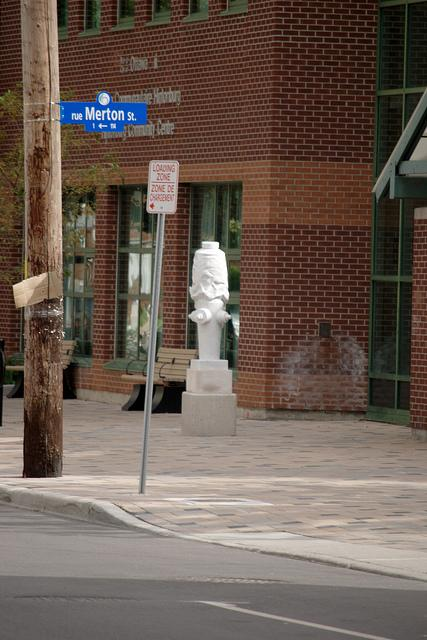The sculpture in front of the building is modeled after what common object found on a sidewalk?

Choices:
A) fire hydrant
B) newspaper box
C) parking meter
D) garbage can fire hydrant 